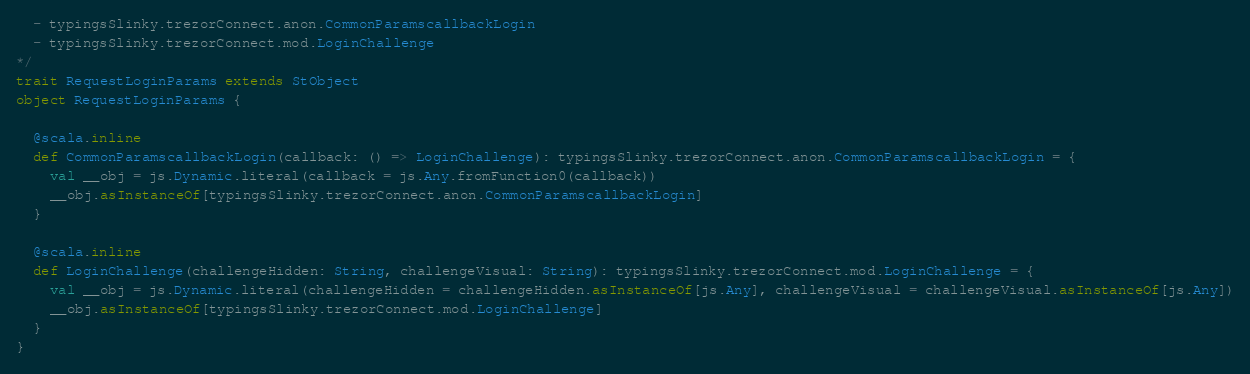Convert code to text. <code><loc_0><loc_0><loc_500><loc_500><_Scala_>  - typingsSlinky.trezorConnect.anon.CommonParamscallbackLogin
  - typingsSlinky.trezorConnect.mod.LoginChallenge
*/
trait RequestLoginParams extends StObject
object RequestLoginParams {
  
  @scala.inline
  def CommonParamscallbackLogin(callback: () => LoginChallenge): typingsSlinky.trezorConnect.anon.CommonParamscallbackLogin = {
    val __obj = js.Dynamic.literal(callback = js.Any.fromFunction0(callback))
    __obj.asInstanceOf[typingsSlinky.trezorConnect.anon.CommonParamscallbackLogin]
  }
  
  @scala.inline
  def LoginChallenge(challengeHidden: String, challengeVisual: String): typingsSlinky.trezorConnect.mod.LoginChallenge = {
    val __obj = js.Dynamic.literal(challengeHidden = challengeHidden.asInstanceOf[js.Any], challengeVisual = challengeVisual.asInstanceOf[js.Any])
    __obj.asInstanceOf[typingsSlinky.trezorConnect.mod.LoginChallenge]
  }
}
</code> 